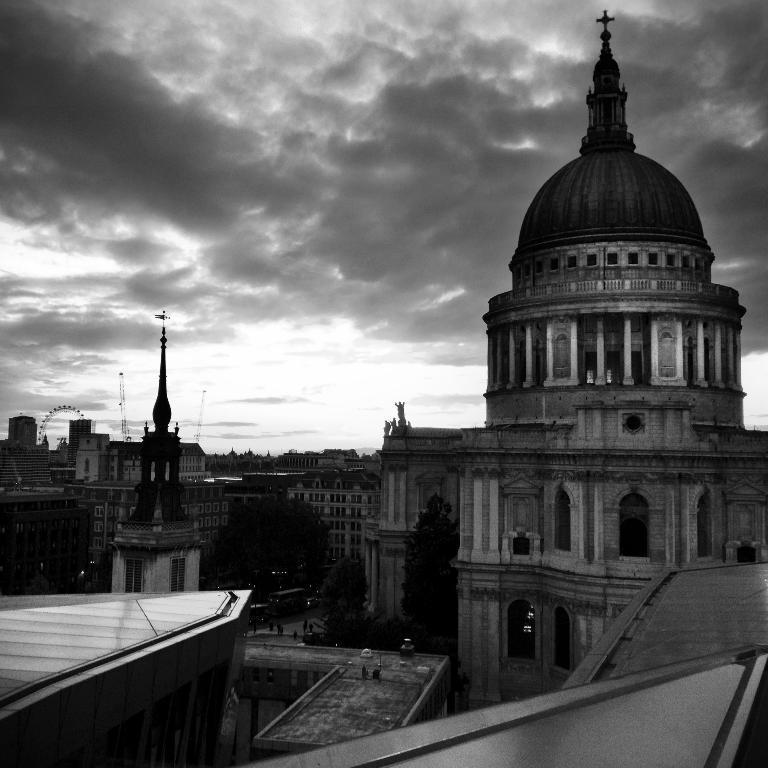Describe this image in one or two sentences. This is a black and white picture. Here we can see buildings, trees, and people. In the background there is sky with clouds. 